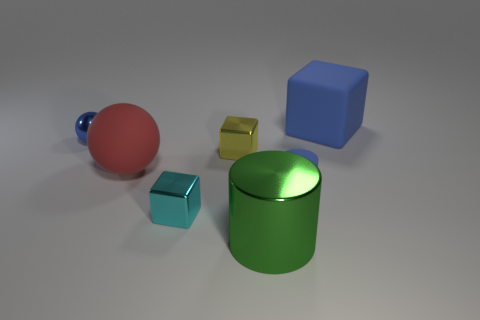There is a blue object behind the small blue metallic thing; is it the same size as the shiny object that is in front of the cyan metallic block?
Offer a terse response. Yes. The blue block that is the same material as the large red ball is what size?
Your answer should be compact. Large. What number of blocks are both right of the big green thing and to the left of the large blue matte thing?
Provide a short and direct response. 0. How many objects are either big yellow balls or big matte objects that are in front of the blue block?
Offer a terse response. 1. The matte object that is the same color as the tiny cylinder is what shape?
Give a very brief answer. Cube. What color is the cube that is in front of the tiny matte cylinder?
Offer a very short reply. Cyan. What number of things are either tiny things that are in front of the blue ball or shiny cubes?
Provide a short and direct response. 3. There is a block that is the same size as the red rubber ball; what color is it?
Offer a terse response. Blue. Are there more shiny cylinders on the right side of the big green shiny cylinder than tiny green matte things?
Offer a terse response. No. What is the material of the big thing that is both to the right of the matte ball and behind the green object?
Provide a short and direct response. Rubber. 